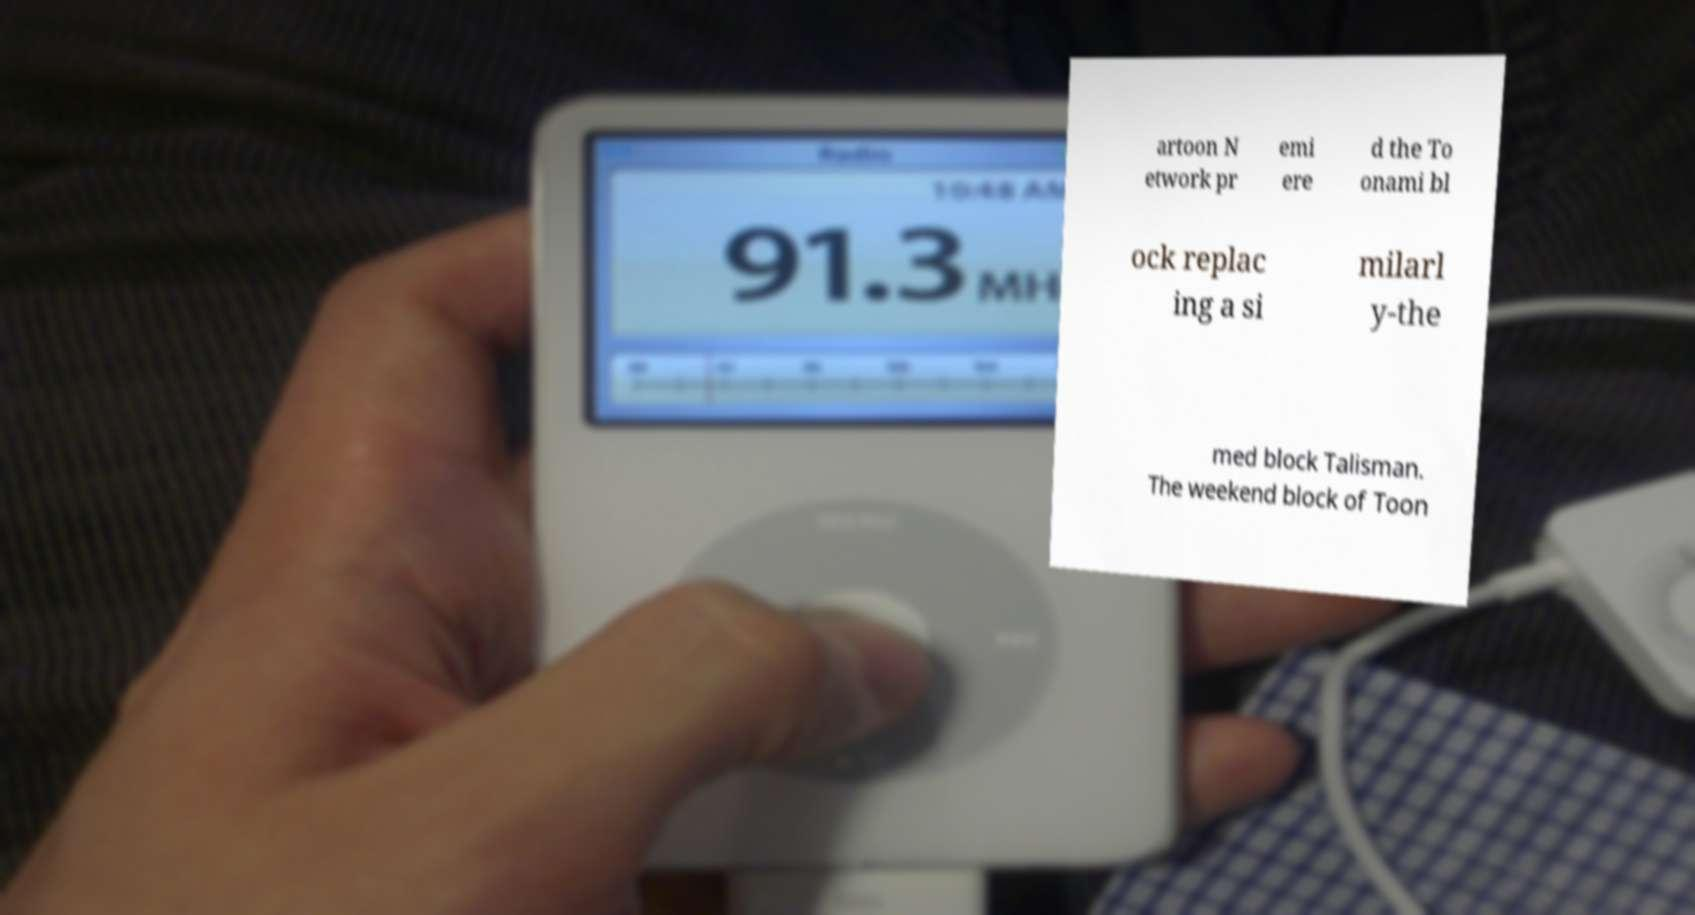Could you extract and type out the text from this image? artoon N etwork pr emi ere d the To onami bl ock replac ing a si milarl y-the med block Talisman. The weekend block of Toon 